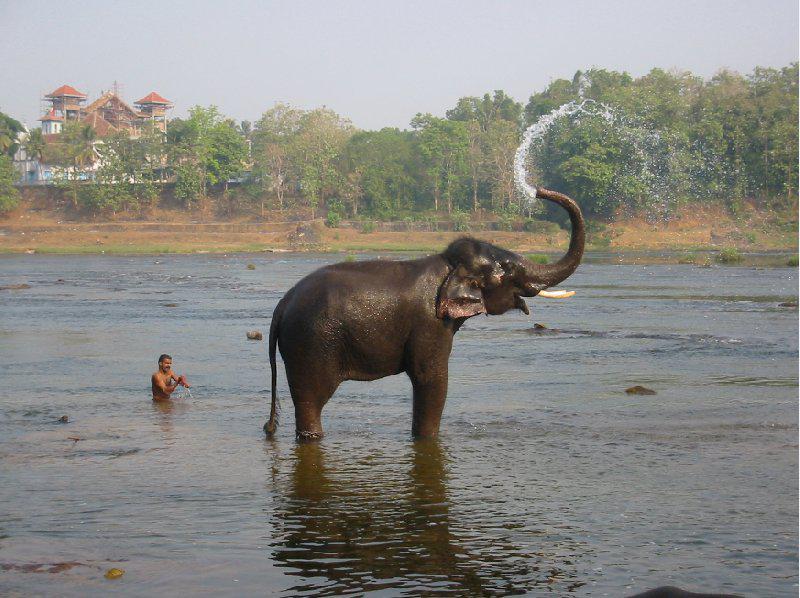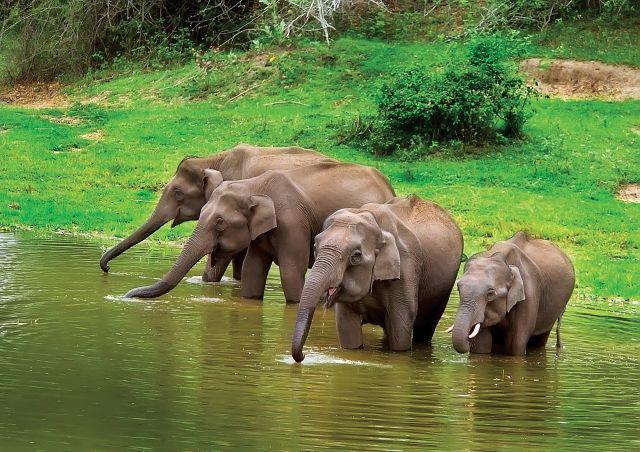The first image is the image on the left, the second image is the image on the right. Analyze the images presented: Is the assertion "One of the images contains exactly four elephants." valid? Answer yes or no. Yes. The first image is the image on the left, the second image is the image on the right. For the images shown, is this caption "There are at least four elephants in the water." true? Answer yes or no. Yes. 